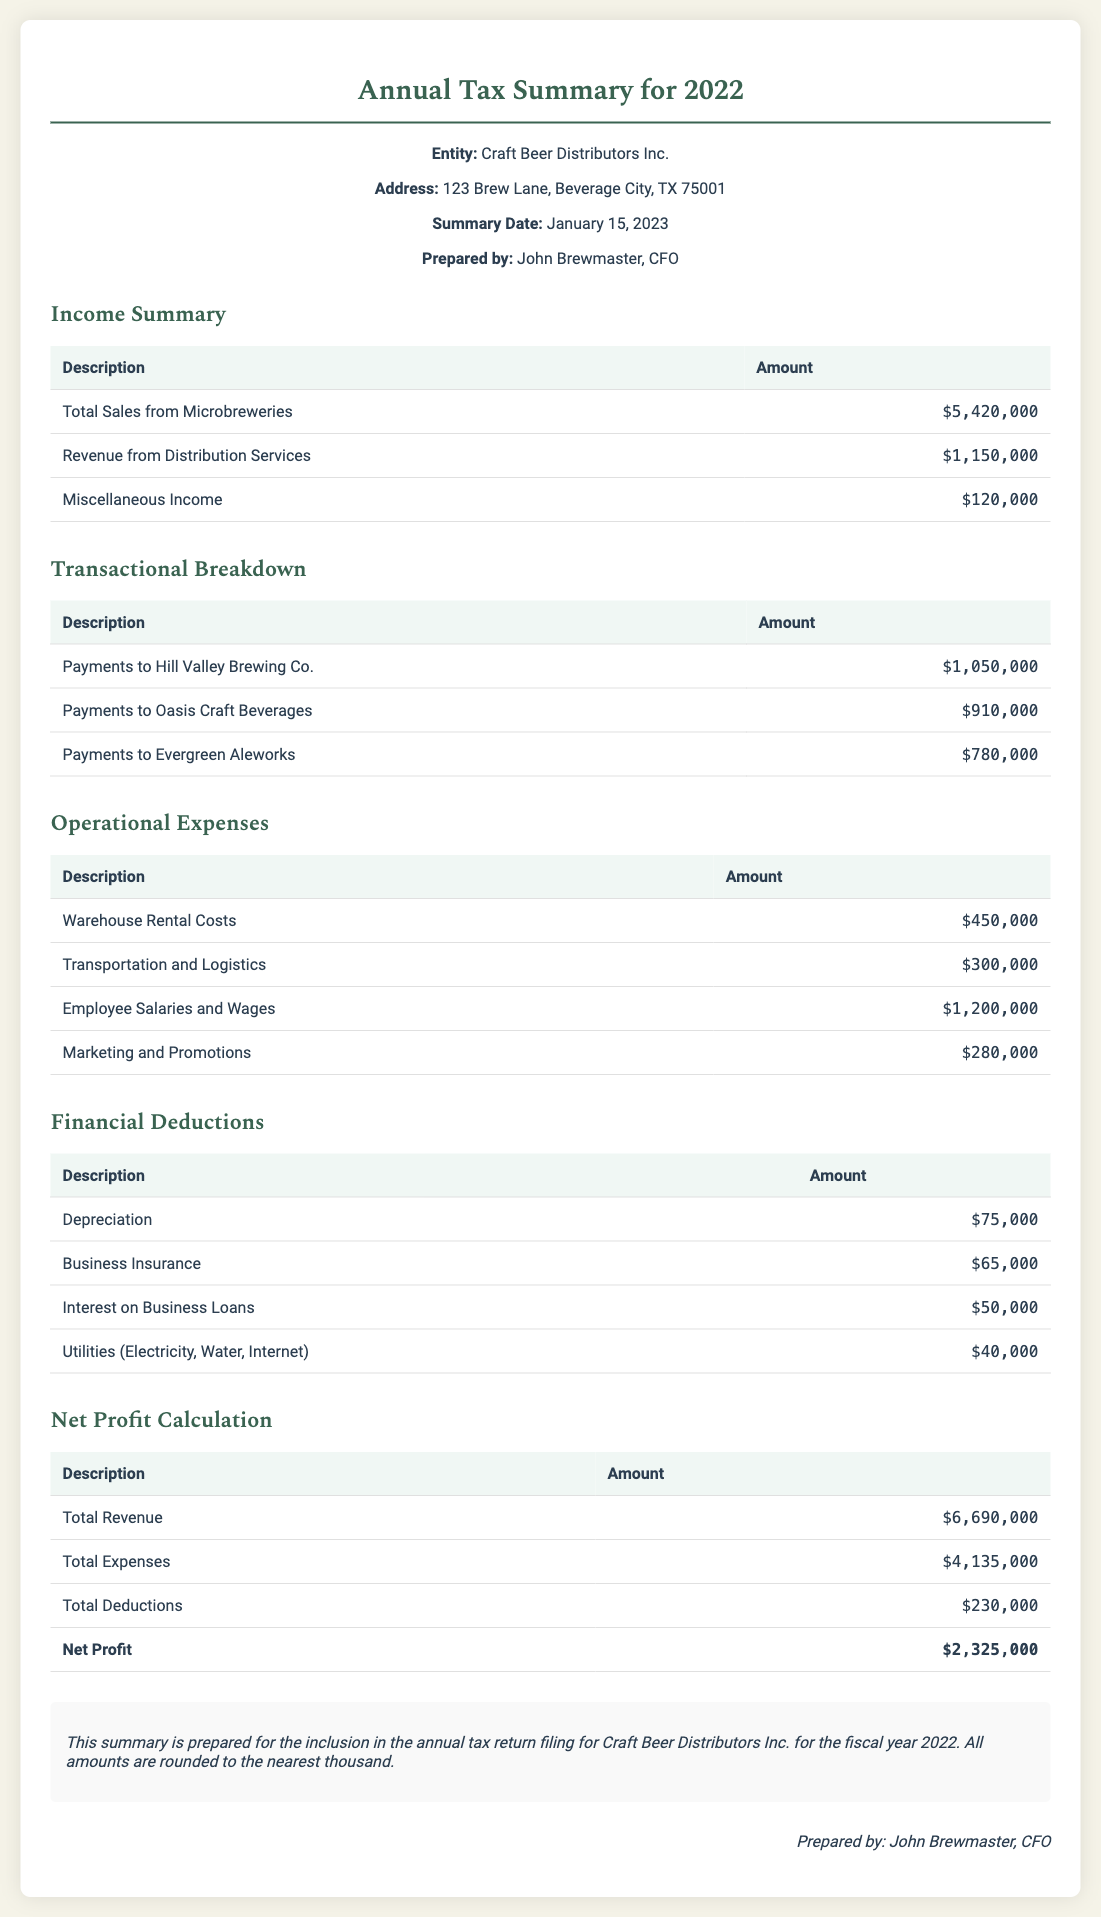What is the total sales from microbreweries? The total sales from microbreweries is explicitly stated in the income summary as $5,420,000.
Answer: $5,420,000 Who is the prepared by individual? The document states the prepared by individual as John Brewmaster, CFO.
Answer: John Brewmaster What is the amount for Business Insurance? The document lists Business Insurance under financial deductions as $65,000.
Answer: $65,000 What are the total operational expenses? The total operational expenses can be calculated by summing the individual amounts listed under operational expenses, which totals $2,230,000.
Answer: $2,230,000 What is the date of the summary? The summary date provided in the document is January 15, 2023.
Answer: January 15, 2023 What is the total net profit? The net profit is highlighted in the net profit calculation section and is $2,325,000, calculated after deducting total expenses and deductions from total revenue.
Answer: $2,325,000 What is the address of Craft Beer Distributors Inc.? The address for Craft Beer Distributors Inc. is listed as 123 Brew Lane, Beverage City, TX 75001.
Answer: 123 Brew Lane, Beverage City, TX 75001 How much did Craft Beer Distributors pay to Oasis Craft Beverages? The payment to Oasis Craft Beverages is mentioned in the transactional breakdown as $910,000.
Answer: $910,000 What is the total deduction amount? The total deductions stated in the document is $230,000.
Answer: $230,000 